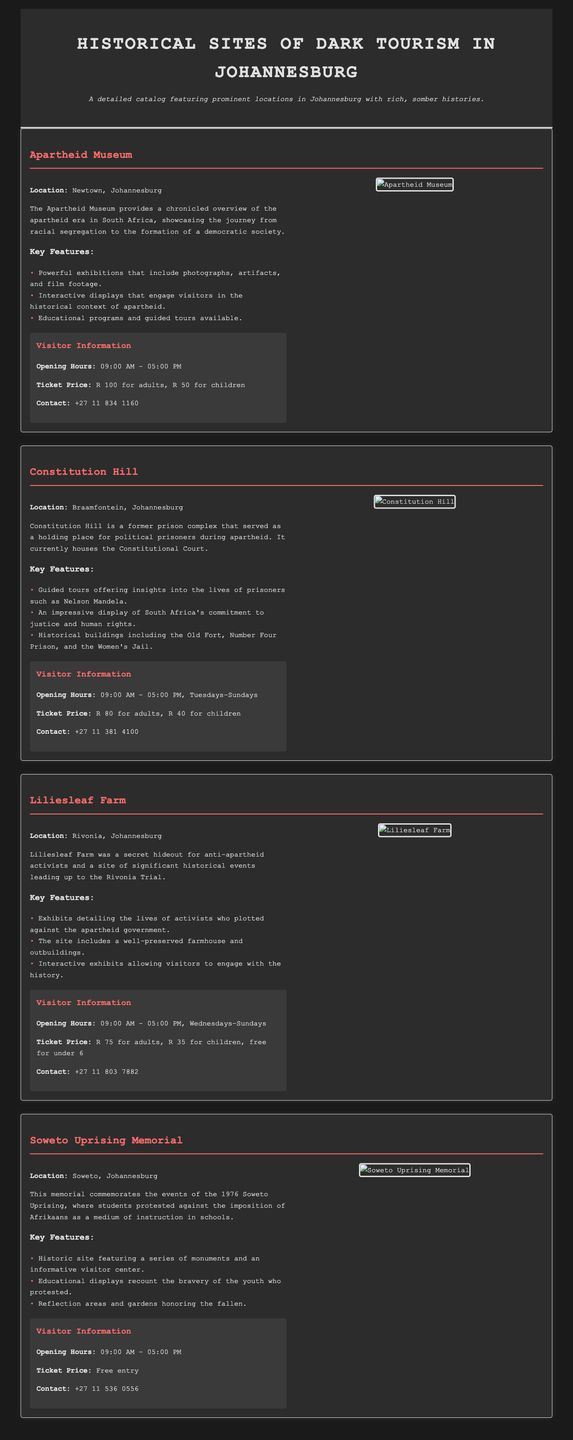What is the location of the Apartheid Museum? The Apartheid Museum is located in Newtown, Johannesburg.
Answer: Newtown, Johannesburg What time does Constitution Hill open? Constitution Hill opens at 09:00 AM.
Answer: 09:00 AM How much is the ticket price for adults at Liliesleaf Farm? The ticket price for adults at Liliesleaf Farm is R 75.
Answer: R 75 Which important historical trial is associated with Liliesleaf Farm? Liliesleaf Farm is associated with the Rivonia Trial.
Answer: Rivonia Trial What kind of features does the Soweto Uprising Memorial have? The Soweto Uprising Memorial features a series of monuments and an informative visitor center.
Answer: Series of monuments and an informative visitor center What are the opening days for Constitution Hill? Constitution Hill is open from Tuesday to Sunday.
Answer: Tuesday to Sunday What unique historical significance does the Apartheid Museum highlight? The Apartheid Museum highlights the journey from racial segregation to the formation of a democratic society.
Answer: Journey from racial segregation to democracy How does the catalog describe historical sites? The catalog describes historical sites featuring prominent locations with rich, somber histories.
Answer: Rich, somber histories 